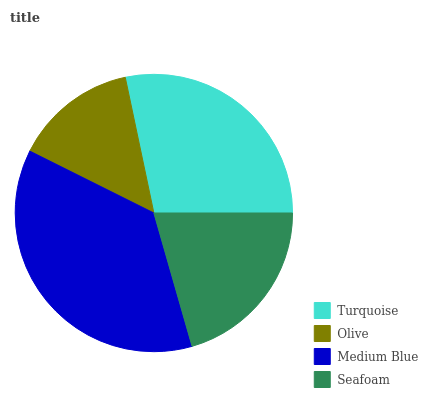Is Olive the minimum?
Answer yes or no. Yes. Is Medium Blue the maximum?
Answer yes or no. Yes. Is Medium Blue the minimum?
Answer yes or no. No. Is Olive the maximum?
Answer yes or no. No. Is Medium Blue greater than Olive?
Answer yes or no. Yes. Is Olive less than Medium Blue?
Answer yes or no. Yes. Is Olive greater than Medium Blue?
Answer yes or no. No. Is Medium Blue less than Olive?
Answer yes or no. No. Is Turquoise the high median?
Answer yes or no. Yes. Is Seafoam the low median?
Answer yes or no. Yes. Is Medium Blue the high median?
Answer yes or no. No. Is Turquoise the low median?
Answer yes or no. No. 